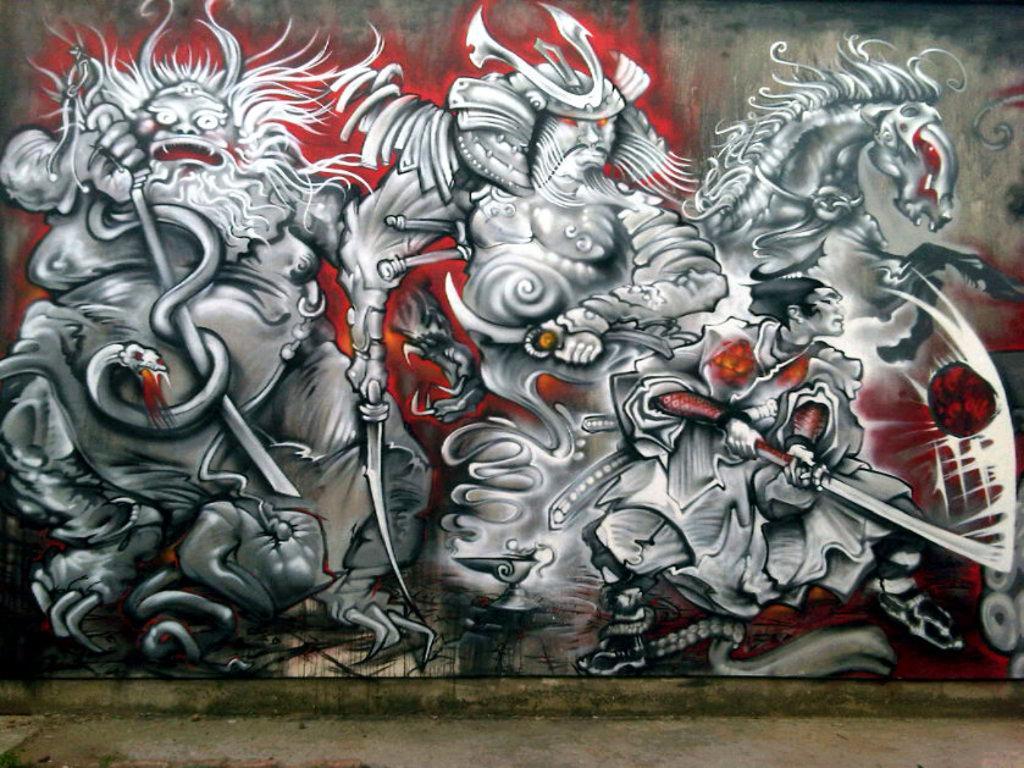How would you summarize this image in a sentence or two? In this image we can see painting on the wall. 